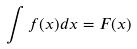Convert formula to latex. <formula><loc_0><loc_0><loc_500><loc_500>\int f ( x ) d x = F ( x )</formula> 